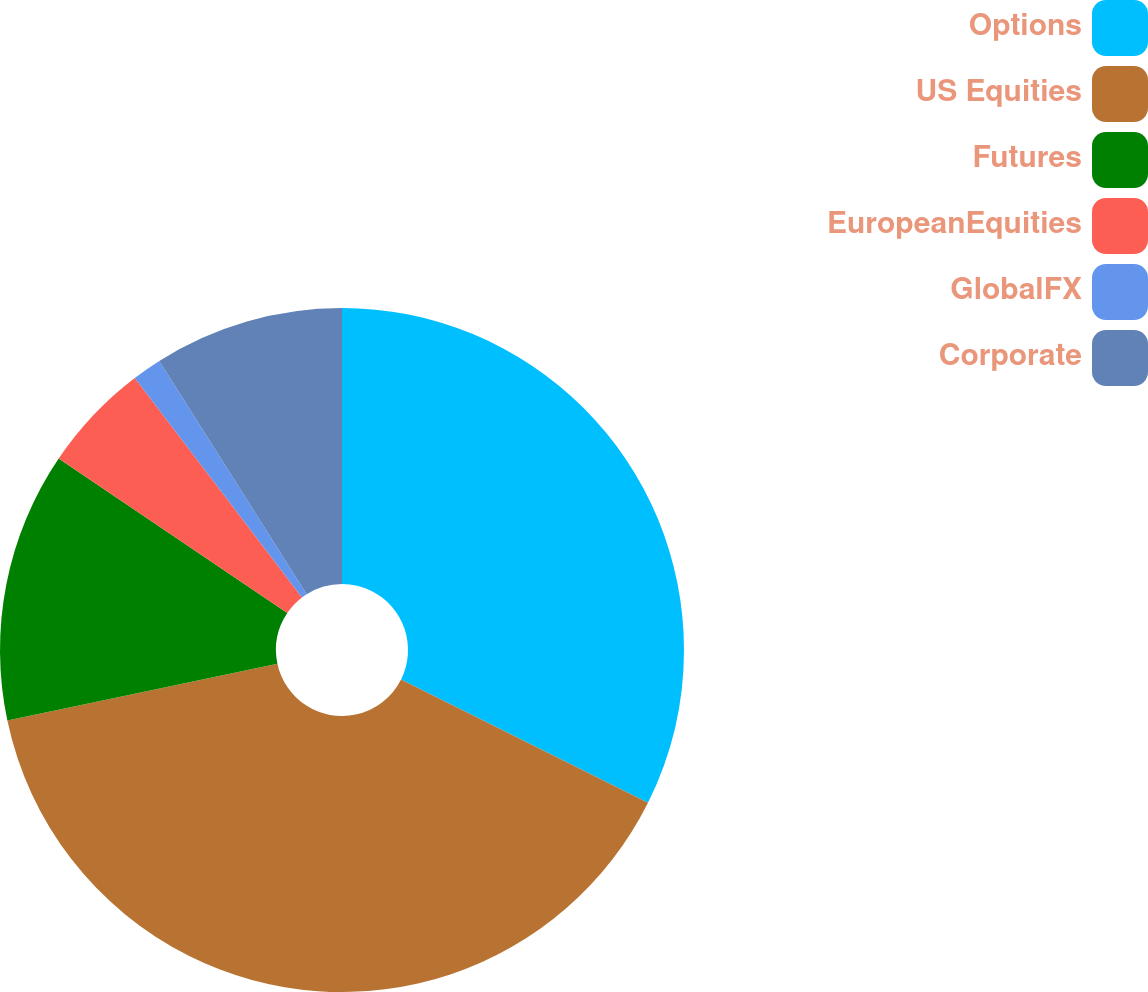Convert chart to OTSL. <chart><loc_0><loc_0><loc_500><loc_500><pie_chart><fcel>Options<fcel>US Equities<fcel>Futures<fcel>EuropeanEquities<fcel>GlobalFX<fcel>Corporate<nl><fcel>32.37%<fcel>39.32%<fcel>12.77%<fcel>5.18%<fcel>1.39%<fcel>8.97%<nl></chart> 